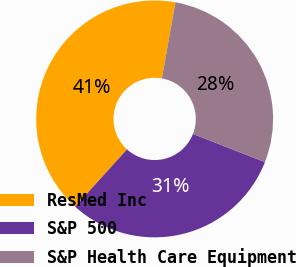Convert chart. <chart><loc_0><loc_0><loc_500><loc_500><pie_chart><fcel>ResMed Inc<fcel>S&P 500<fcel>S&P Health Care Equipment<nl><fcel>41.09%<fcel>30.78%<fcel>28.13%<nl></chart> 